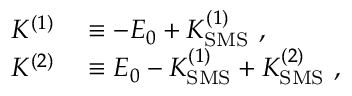<formula> <loc_0><loc_0><loc_500><loc_500>\begin{array} { r l } { K ^ { ( 1 ) } } & \equiv - E _ { 0 } + K _ { S M S } ^ { ( 1 ) } \ , } \\ { K ^ { ( 2 ) } } & \equiv E _ { 0 } - K _ { S M S } ^ { ( 1 ) } + K _ { S M S } ^ { ( 2 ) } \ , } \end{array}</formula> 